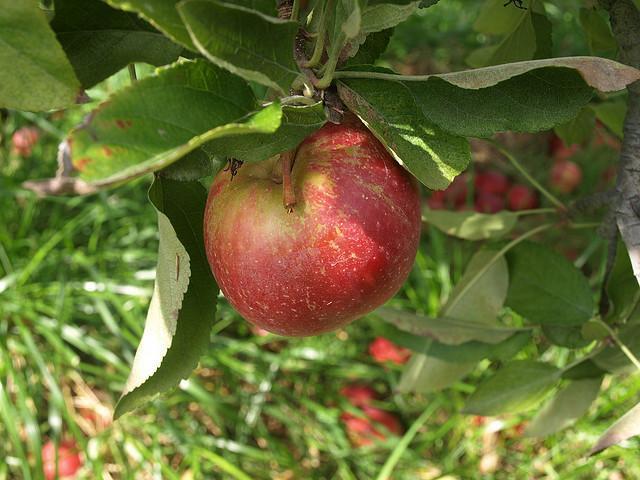How many apples can be seen?
Give a very brief answer. 2. 